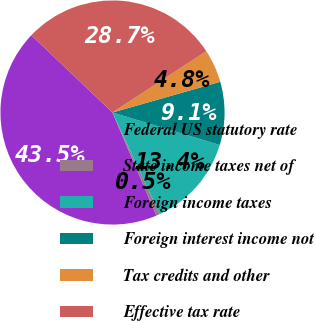Convert chart to OTSL. <chart><loc_0><loc_0><loc_500><loc_500><pie_chart><fcel>Federal US statutory rate<fcel>State income taxes net of<fcel>Foreign income taxes<fcel>Foreign interest income not<fcel>Tax credits and other<fcel>Effective tax rate<nl><fcel>43.52%<fcel>0.5%<fcel>13.4%<fcel>9.1%<fcel>4.8%<fcel>28.67%<nl></chart> 